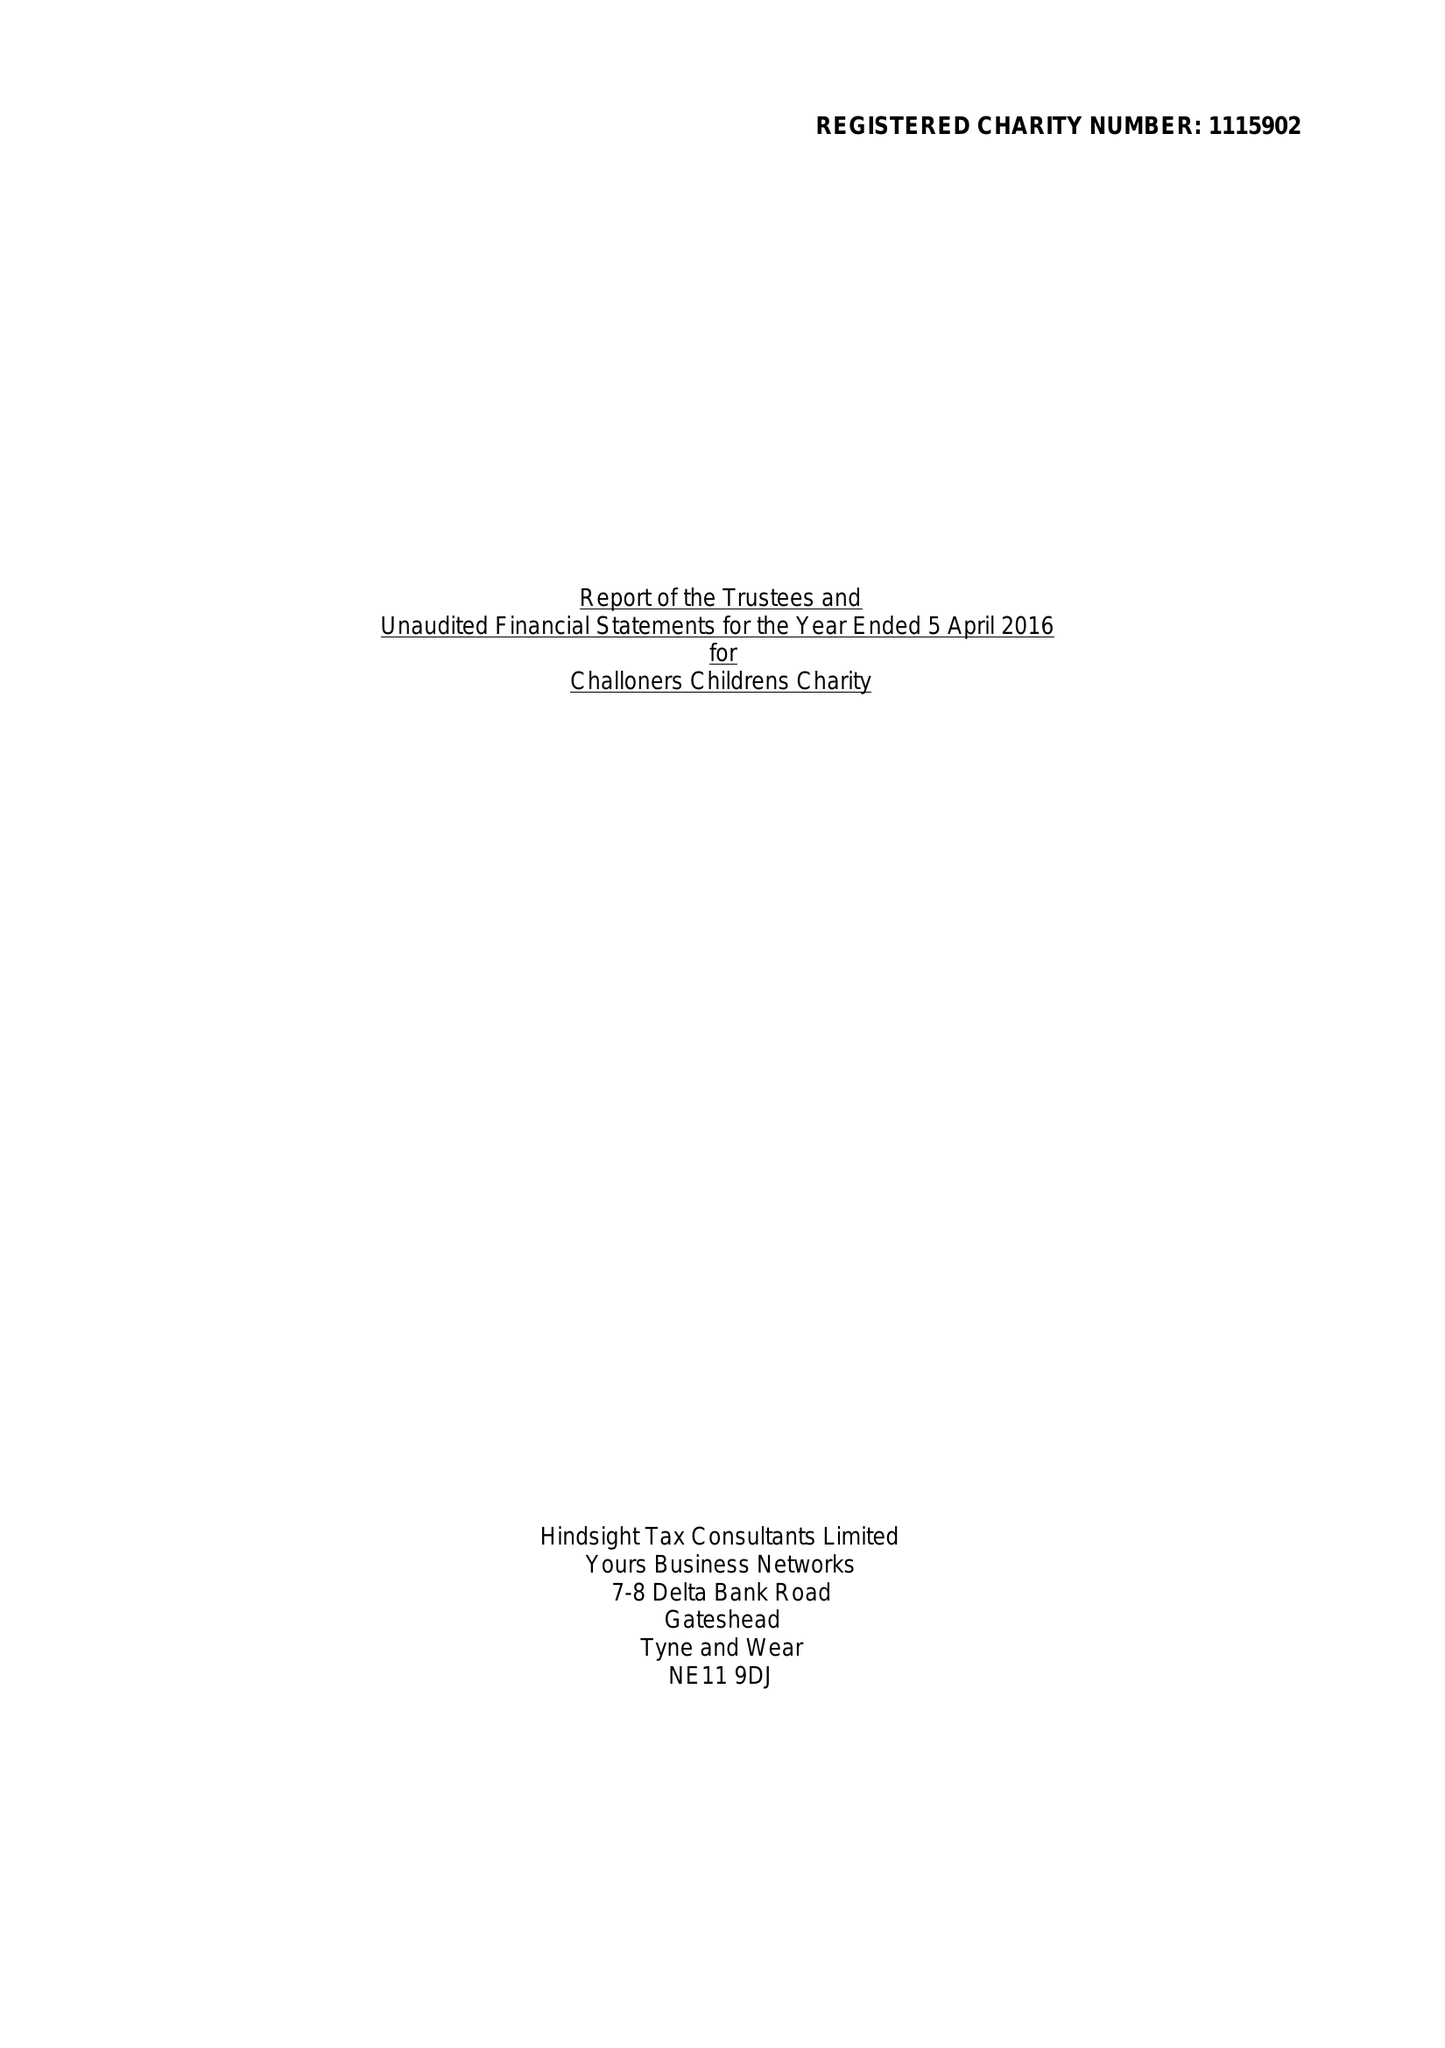What is the value for the charity_number?
Answer the question using a single word or phrase. 1115902 